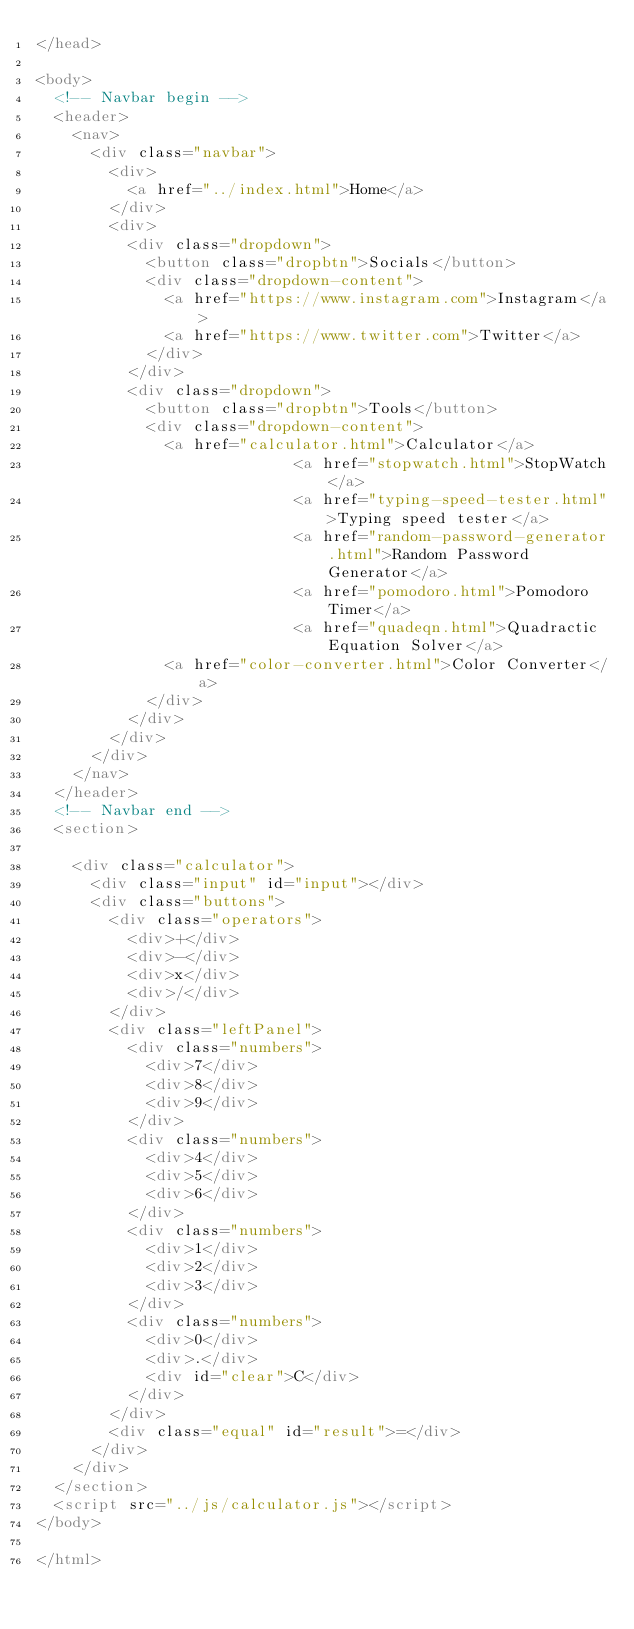<code> <loc_0><loc_0><loc_500><loc_500><_HTML_></head>

<body>
	<!-- Navbar begin -->
	<header>
		<nav>
			<div class="navbar">
				<div>
					<a href="../index.html">Home</a>
				</div>
				<div>
					<div class="dropdown">
						<button class="dropbtn">Socials</button>
						<div class="dropdown-content">
							<a href="https://www.instagram.com">Instagram</a>
							<a href="https://www.twitter.com">Twitter</a>
						</div>
					</div>
					<div class="dropdown">
						<button class="dropbtn">Tools</button>
						<div class="dropdown-content">
							<a href="calculator.html">Calculator</a>
                            <a href="stopwatch.html">StopWatch</a>
                            <a href="typing-speed-tester.html">Typing speed tester</a>
                            <a href="random-password-generator.html">Random Password Generator</a>
                            <a href="pomodoro.html">Pomodoro Timer</a>
                            <a href="quadeqn.html">Quadractic Equation Solver</a>
							<a href="color-converter.html">Color Converter</a>
						</div>
					</div>
				</div>
			</div>
		</nav>
	</header>
	<!-- Navbar end -->
	<section>

		<div class="calculator">
			<div class="input" id="input"></div>
			<div class="buttons">
				<div class="operators">
					<div>+</div>
					<div>-</div>
					<div>x</div>
					<div>/</div>
				</div>
				<div class="leftPanel">
					<div class="numbers">
						<div>7</div>
						<div>8</div>
						<div>9</div>
					</div>
					<div class="numbers">
						<div>4</div>
						<div>5</div>
						<div>6</div>
					</div>
					<div class="numbers">
						<div>1</div>
						<div>2</div>
						<div>3</div>
					</div>
					<div class="numbers">
						<div>0</div>
						<div>.</div>
						<div id="clear">C</div>
					</div>
				</div>
				<div class="equal" id="result">=</div>
			</div>
		</div>
	</section>
	<script src="../js/calculator.js"></script>
</body>

</html></code> 